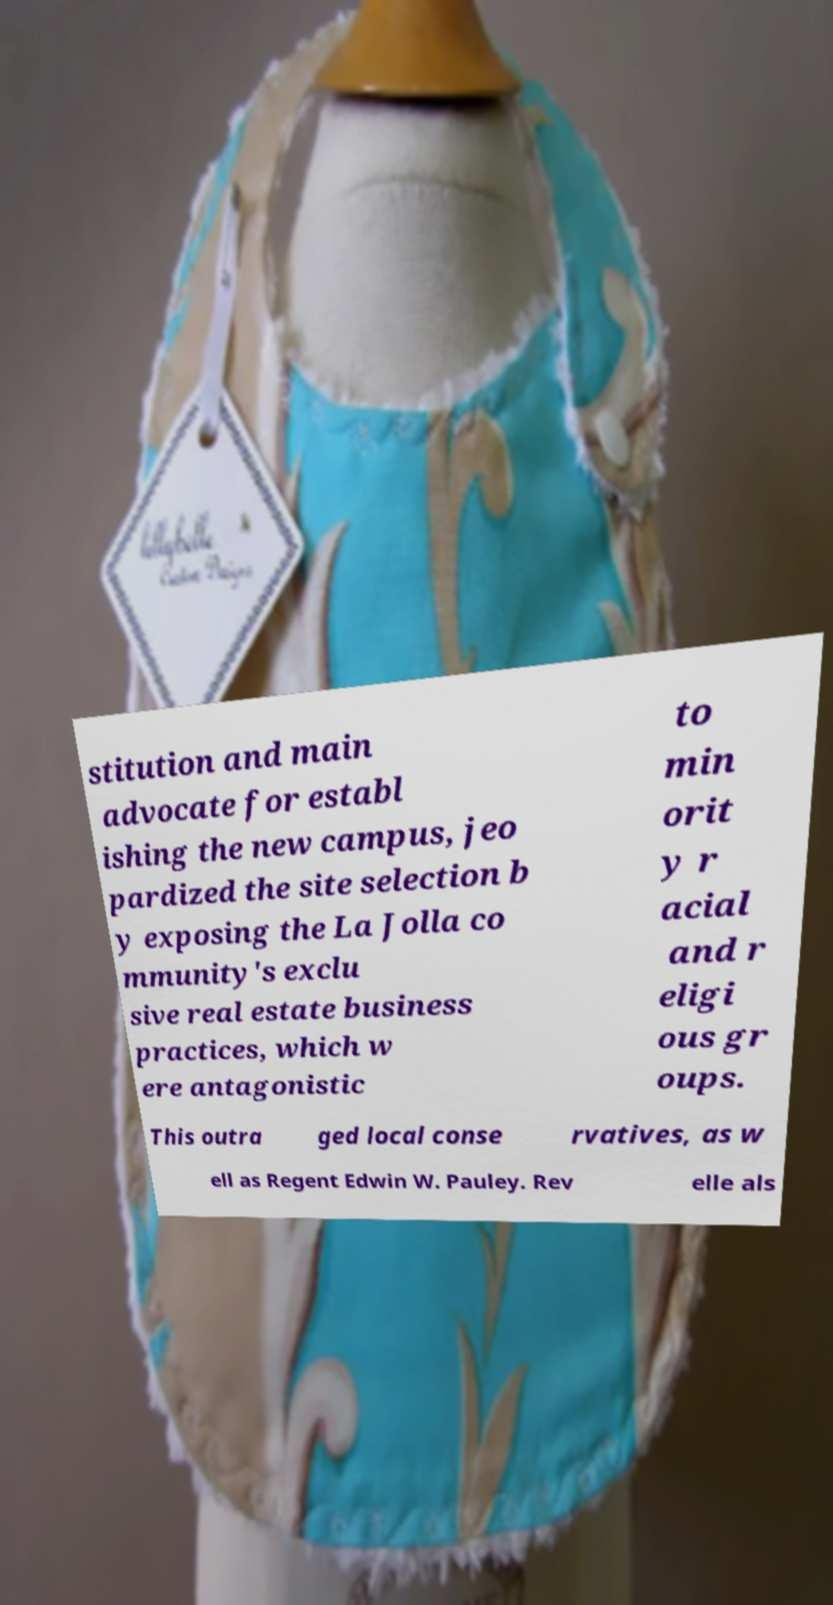For documentation purposes, I need the text within this image transcribed. Could you provide that? stitution and main advocate for establ ishing the new campus, jeo pardized the site selection b y exposing the La Jolla co mmunity's exclu sive real estate business practices, which w ere antagonistic to min orit y r acial and r eligi ous gr oups. This outra ged local conse rvatives, as w ell as Regent Edwin W. Pauley. Rev elle als 